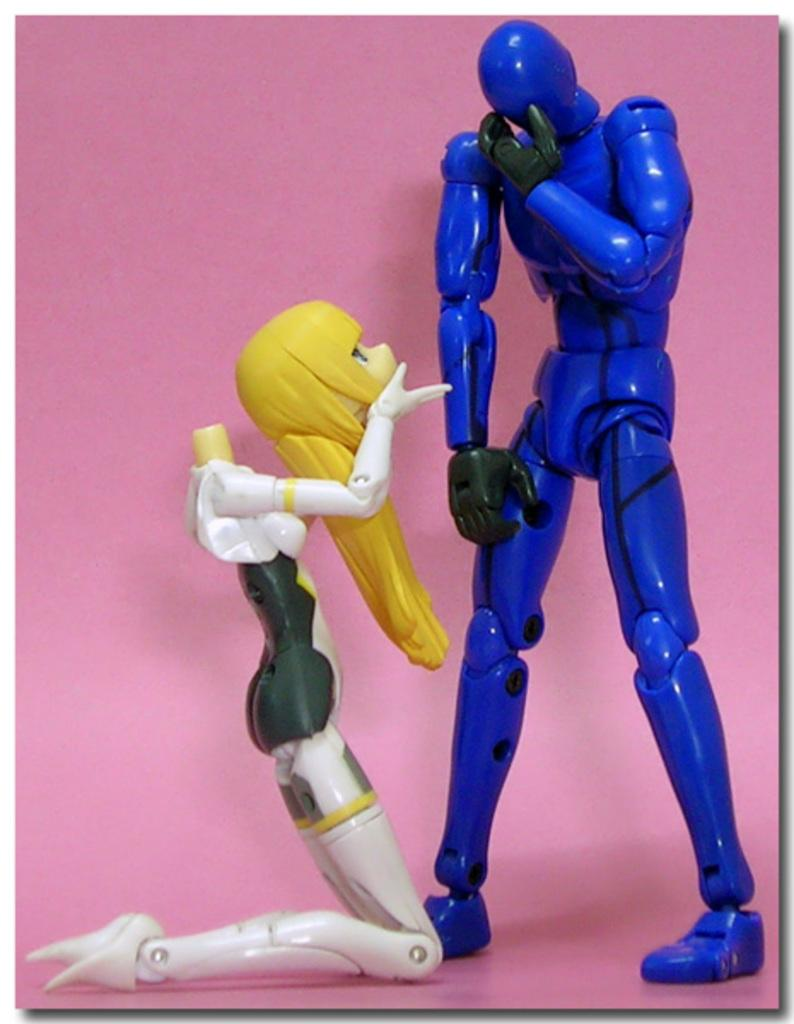How many toys can be seen in the image? There are two toys in the image. Where are the toys located? The toys are placed on a surface. What type of pipe can be seen connecting the toys in the image? There is no pipe connecting the toys in the image, as the facts only mention the presence of two toys placed on a surface. 